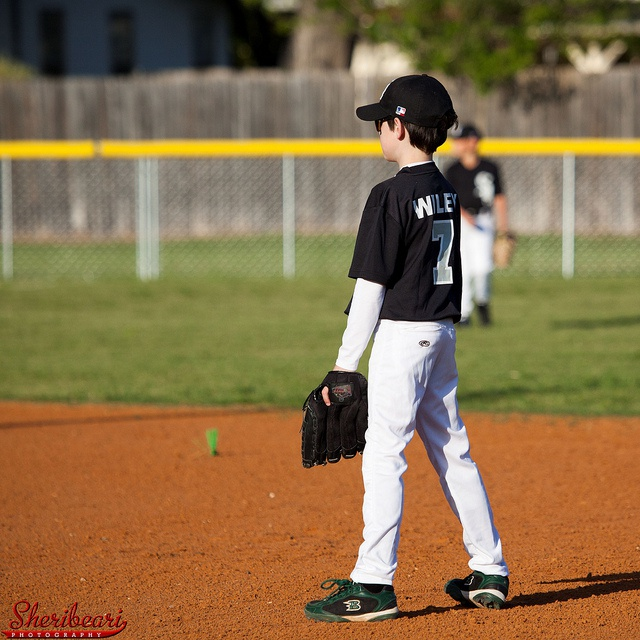Describe the objects in this image and their specific colors. I can see people in black, white, and gray tones, people in black, lightgray, darkgray, and gray tones, baseball glove in black, gray, and maroon tones, and baseball glove in black, tan, and gray tones in this image. 